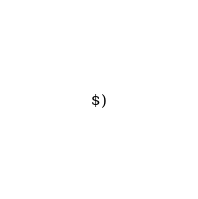Convert code to text. <code><loc_0><loc_0><loc_500><loc_500><_ObjectiveC_>$)
</code> 